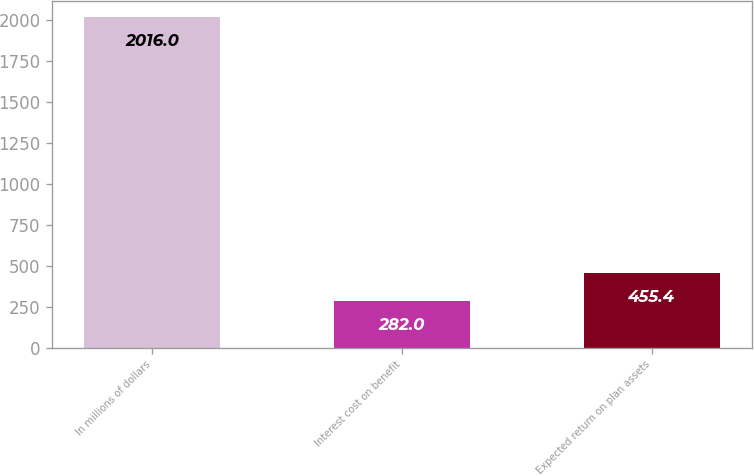Convert chart to OTSL. <chart><loc_0><loc_0><loc_500><loc_500><bar_chart><fcel>In millions of dollars<fcel>Interest cost on benefit<fcel>Expected return on plan assets<nl><fcel>2016<fcel>282<fcel>455.4<nl></chart> 